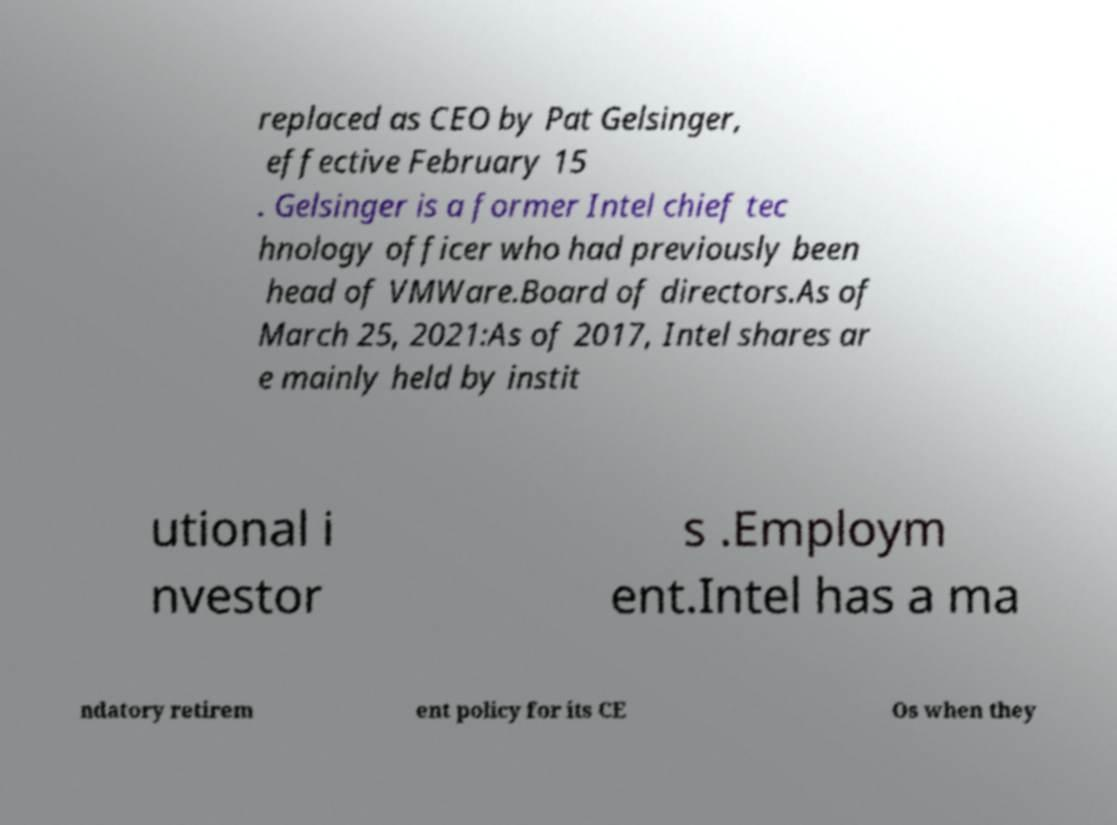Could you extract and type out the text from this image? replaced as CEO by Pat Gelsinger, effective February 15 . Gelsinger is a former Intel chief tec hnology officer who had previously been head of VMWare.Board of directors.As of March 25, 2021:As of 2017, Intel shares ar e mainly held by instit utional i nvestor s .Employm ent.Intel has a ma ndatory retirem ent policy for its CE Os when they 